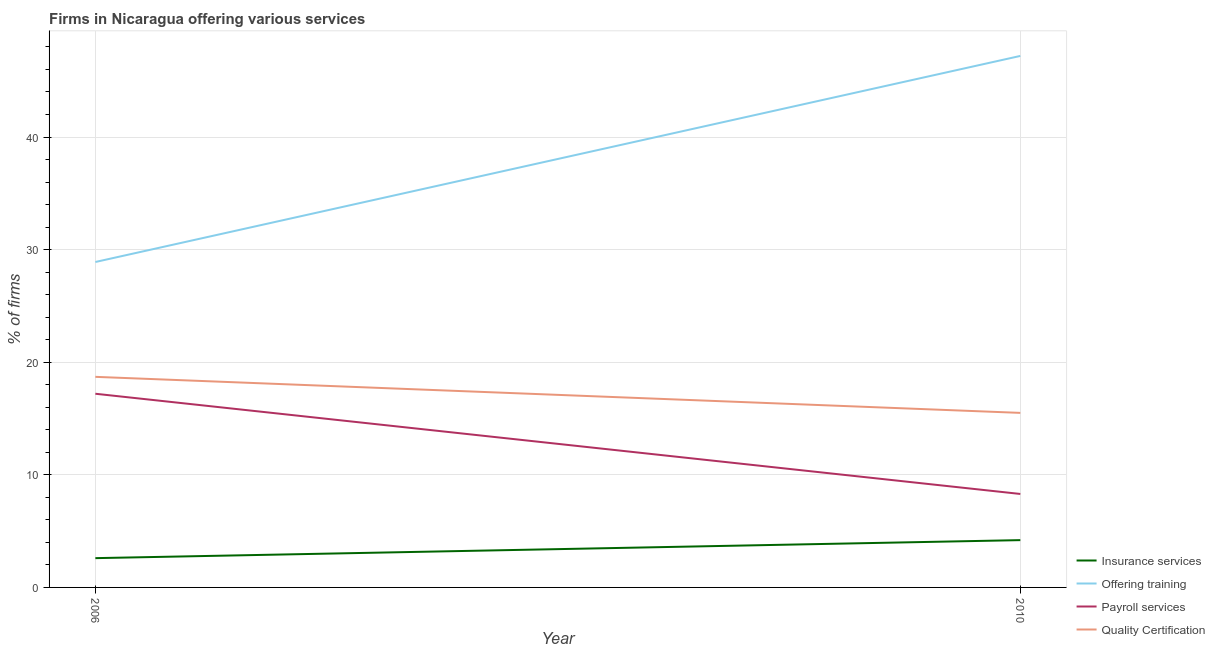How many different coloured lines are there?
Give a very brief answer. 4. Does the line corresponding to percentage of firms offering training intersect with the line corresponding to percentage of firms offering payroll services?
Make the answer very short. No. What is the percentage of firms offering training in 2006?
Offer a very short reply. 28.9. In which year was the percentage of firms offering quality certification maximum?
Make the answer very short. 2006. What is the total percentage of firms offering quality certification in the graph?
Offer a terse response. 34.2. What is the difference between the percentage of firms offering payroll services in 2006 and that in 2010?
Provide a short and direct response. 8.9. What is the difference between the percentage of firms offering insurance services in 2006 and the percentage of firms offering quality certification in 2010?
Offer a terse response. -12.9. What is the average percentage of firms offering training per year?
Your answer should be very brief. 38.05. In the year 2010, what is the difference between the percentage of firms offering training and percentage of firms offering payroll services?
Ensure brevity in your answer.  38.9. In how many years, is the percentage of firms offering quality certification greater than 16 %?
Your answer should be very brief. 1. What is the ratio of the percentage of firms offering training in 2006 to that in 2010?
Offer a very short reply. 0.61. Is the percentage of firms offering training in 2006 less than that in 2010?
Offer a terse response. Yes. In how many years, is the percentage of firms offering payroll services greater than the average percentage of firms offering payroll services taken over all years?
Make the answer very short. 1. Is the percentage of firms offering payroll services strictly greater than the percentage of firms offering quality certification over the years?
Make the answer very short. No. Is the percentage of firms offering insurance services strictly less than the percentage of firms offering payroll services over the years?
Your answer should be very brief. Yes. How many lines are there?
Your response must be concise. 4. Are the values on the major ticks of Y-axis written in scientific E-notation?
Your response must be concise. No. Does the graph contain grids?
Your answer should be very brief. Yes. How many legend labels are there?
Keep it short and to the point. 4. What is the title of the graph?
Your answer should be compact. Firms in Nicaragua offering various services . What is the label or title of the Y-axis?
Offer a very short reply. % of firms. What is the % of firms of Offering training in 2006?
Give a very brief answer. 28.9. What is the % of firms in Quality Certification in 2006?
Give a very brief answer. 18.7. What is the % of firms in Offering training in 2010?
Give a very brief answer. 47.2. What is the % of firms in Payroll services in 2010?
Provide a short and direct response. 8.3. What is the % of firms of Quality Certification in 2010?
Offer a very short reply. 15.5. Across all years, what is the maximum % of firms of Insurance services?
Ensure brevity in your answer.  4.2. Across all years, what is the maximum % of firms of Offering training?
Your response must be concise. 47.2. Across all years, what is the maximum % of firms in Payroll services?
Provide a short and direct response. 17.2. Across all years, what is the minimum % of firms of Insurance services?
Offer a very short reply. 2.6. Across all years, what is the minimum % of firms in Offering training?
Your response must be concise. 28.9. Across all years, what is the minimum % of firms of Quality Certification?
Your answer should be compact. 15.5. What is the total % of firms of Offering training in the graph?
Ensure brevity in your answer.  76.1. What is the total % of firms in Quality Certification in the graph?
Your answer should be very brief. 34.2. What is the difference between the % of firms of Insurance services in 2006 and that in 2010?
Make the answer very short. -1.6. What is the difference between the % of firms of Offering training in 2006 and that in 2010?
Offer a terse response. -18.3. What is the difference between the % of firms of Payroll services in 2006 and that in 2010?
Ensure brevity in your answer.  8.9. What is the difference between the % of firms in Insurance services in 2006 and the % of firms in Offering training in 2010?
Provide a short and direct response. -44.6. What is the difference between the % of firms in Insurance services in 2006 and the % of firms in Quality Certification in 2010?
Your answer should be very brief. -12.9. What is the difference between the % of firms in Offering training in 2006 and the % of firms in Payroll services in 2010?
Keep it short and to the point. 20.6. What is the difference between the % of firms of Offering training in 2006 and the % of firms of Quality Certification in 2010?
Provide a short and direct response. 13.4. What is the average % of firms of Offering training per year?
Offer a terse response. 38.05. What is the average % of firms of Payroll services per year?
Offer a terse response. 12.75. What is the average % of firms in Quality Certification per year?
Your answer should be compact. 17.1. In the year 2006, what is the difference between the % of firms in Insurance services and % of firms in Offering training?
Give a very brief answer. -26.3. In the year 2006, what is the difference between the % of firms of Insurance services and % of firms of Payroll services?
Your response must be concise. -14.6. In the year 2006, what is the difference between the % of firms of Insurance services and % of firms of Quality Certification?
Provide a short and direct response. -16.1. In the year 2006, what is the difference between the % of firms in Payroll services and % of firms in Quality Certification?
Keep it short and to the point. -1.5. In the year 2010, what is the difference between the % of firms in Insurance services and % of firms in Offering training?
Ensure brevity in your answer.  -43. In the year 2010, what is the difference between the % of firms of Offering training and % of firms of Payroll services?
Make the answer very short. 38.9. In the year 2010, what is the difference between the % of firms of Offering training and % of firms of Quality Certification?
Provide a succinct answer. 31.7. What is the ratio of the % of firms in Insurance services in 2006 to that in 2010?
Ensure brevity in your answer.  0.62. What is the ratio of the % of firms of Offering training in 2006 to that in 2010?
Offer a terse response. 0.61. What is the ratio of the % of firms in Payroll services in 2006 to that in 2010?
Offer a terse response. 2.07. What is the ratio of the % of firms of Quality Certification in 2006 to that in 2010?
Offer a terse response. 1.21. What is the difference between the highest and the second highest % of firms in Insurance services?
Give a very brief answer. 1.6. What is the difference between the highest and the second highest % of firms of Quality Certification?
Make the answer very short. 3.2. What is the difference between the highest and the lowest % of firms of Insurance services?
Your answer should be compact. 1.6. What is the difference between the highest and the lowest % of firms of Offering training?
Your response must be concise. 18.3. What is the difference between the highest and the lowest % of firms in Payroll services?
Provide a succinct answer. 8.9. What is the difference between the highest and the lowest % of firms in Quality Certification?
Provide a short and direct response. 3.2. 